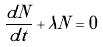Convert formula to latex. <formula><loc_0><loc_0><loc_500><loc_500>\frac { d N } { d t } + \lambda N = 0</formula> 